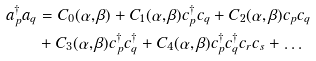<formula> <loc_0><loc_0><loc_500><loc_500>a _ { p } ^ { \dag } a _ { q } & = C _ { 0 } ( \alpha , \beta ) + C _ { 1 } ( \alpha , \beta ) c _ { p } ^ { \dag } c _ { q } + C _ { 2 } ( \alpha , \beta ) c _ { p } c _ { q } \\ & + C _ { 3 } ( \alpha , \beta ) c _ { p } ^ { \dag } c _ { q } ^ { \dag } + C _ { 4 } ( \alpha , \beta ) c _ { p } ^ { \dag } c _ { q } ^ { \dag } c _ { r } c _ { s } + \dots</formula> 